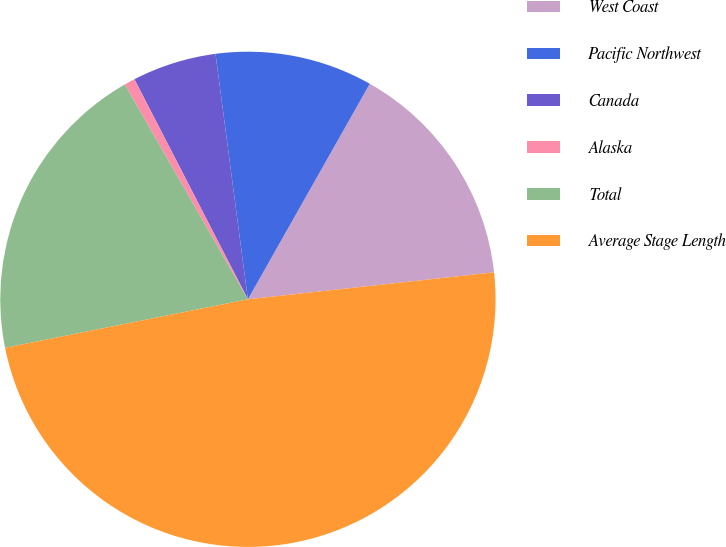Convert chart. <chart><loc_0><loc_0><loc_500><loc_500><pie_chart><fcel>West Coast<fcel>Pacific Northwest<fcel>Canada<fcel>Alaska<fcel>Total<fcel>Average Stage Length<nl><fcel>15.07%<fcel>10.28%<fcel>5.49%<fcel>0.7%<fcel>19.86%<fcel>48.6%<nl></chart> 